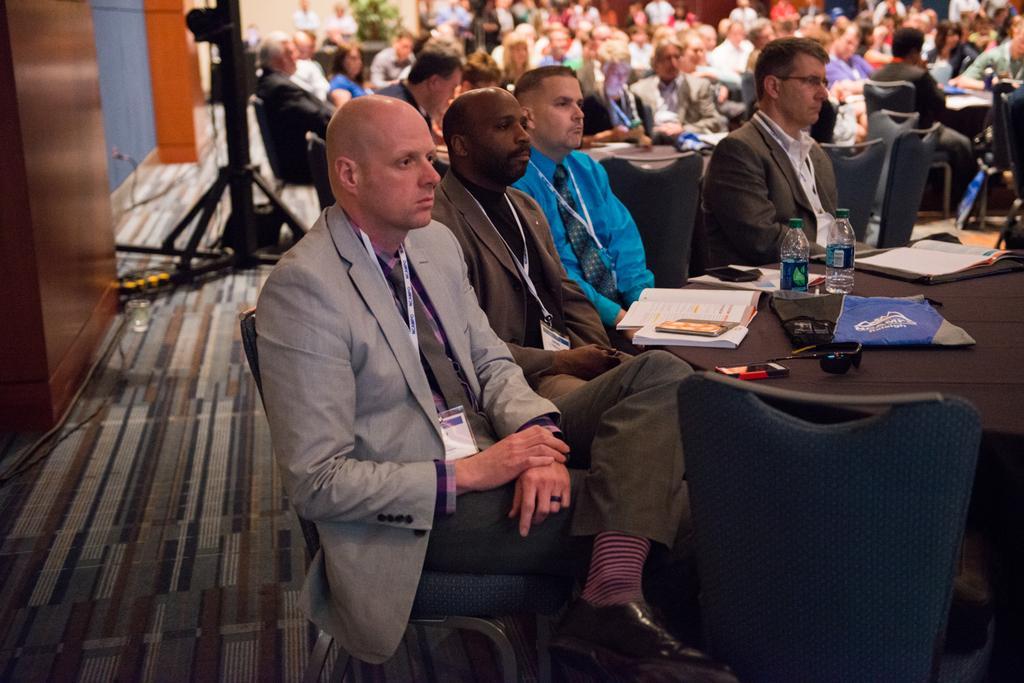Describe this image in one or two sentences. As we can see in the image there are group of people sitting on chairs and there are tables. On table there is a book, bottles, cloth and paper. 